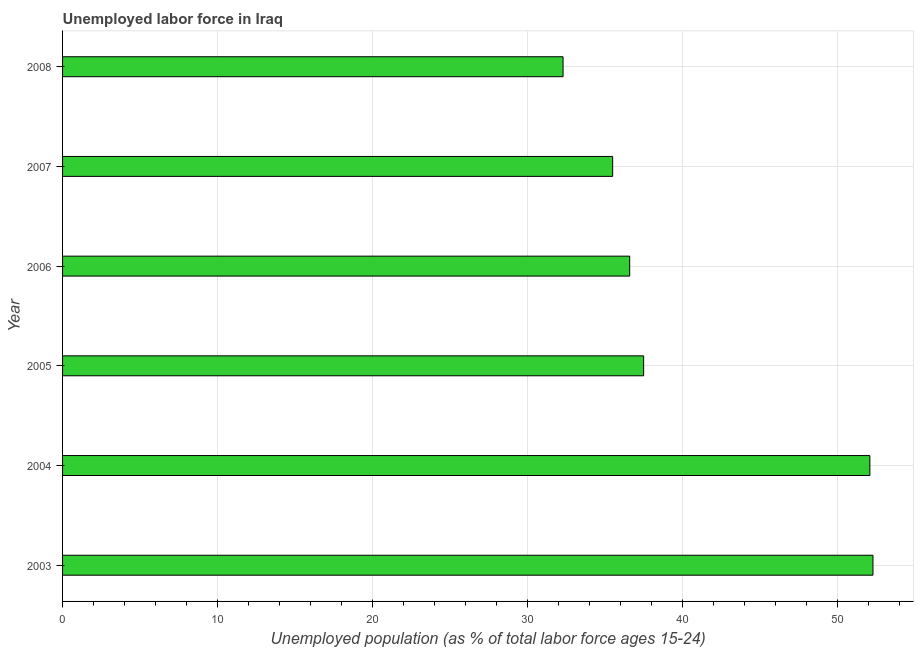Does the graph contain grids?
Provide a succinct answer. Yes. What is the title of the graph?
Offer a very short reply. Unemployed labor force in Iraq. What is the label or title of the X-axis?
Ensure brevity in your answer.  Unemployed population (as % of total labor force ages 15-24). What is the label or title of the Y-axis?
Offer a terse response. Year. What is the total unemployed youth population in 2004?
Your answer should be very brief. 52.1. Across all years, what is the maximum total unemployed youth population?
Give a very brief answer. 52.3. Across all years, what is the minimum total unemployed youth population?
Offer a very short reply. 32.3. What is the sum of the total unemployed youth population?
Provide a succinct answer. 246.3. What is the difference between the total unemployed youth population in 2003 and 2007?
Provide a succinct answer. 16.8. What is the average total unemployed youth population per year?
Make the answer very short. 41.05. What is the median total unemployed youth population?
Make the answer very short. 37.05. In how many years, is the total unemployed youth population greater than 22 %?
Offer a very short reply. 6. What is the ratio of the total unemployed youth population in 2007 to that in 2008?
Your answer should be very brief. 1.1. Is the total unemployed youth population in 2006 less than that in 2008?
Your answer should be compact. No. Is the difference between the total unemployed youth population in 2004 and 2007 greater than the difference between any two years?
Your response must be concise. No. What is the difference between the highest and the second highest total unemployed youth population?
Keep it short and to the point. 0.2. What is the difference between the highest and the lowest total unemployed youth population?
Your answer should be compact. 20. How many bars are there?
Offer a very short reply. 6. Are all the bars in the graph horizontal?
Provide a succinct answer. Yes. What is the difference between two consecutive major ticks on the X-axis?
Ensure brevity in your answer.  10. What is the Unemployed population (as % of total labor force ages 15-24) of 2003?
Offer a terse response. 52.3. What is the Unemployed population (as % of total labor force ages 15-24) of 2004?
Offer a terse response. 52.1. What is the Unemployed population (as % of total labor force ages 15-24) of 2005?
Make the answer very short. 37.5. What is the Unemployed population (as % of total labor force ages 15-24) in 2006?
Offer a terse response. 36.6. What is the Unemployed population (as % of total labor force ages 15-24) of 2007?
Provide a succinct answer. 35.5. What is the Unemployed population (as % of total labor force ages 15-24) in 2008?
Provide a short and direct response. 32.3. What is the difference between the Unemployed population (as % of total labor force ages 15-24) in 2003 and 2005?
Ensure brevity in your answer.  14.8. What is the difference between the Unemployed population (as % of total labor force ages 15-24) in 2003 and 2007?
Your answer should be compact. 16.8. What is the difference between the Unemployed population (as % of total labor force ages 15-24) in 2003 and 2008?
Provide a short and direct response. 20. What is the difference between the Unemployed population (as % of total labor force ages 15-24) in 2004 and 2005?
Provide a short and direct response. 14.6. What is the difference between the Unemployed population (as % of total labor force ages 15-24) in 2004 and 2008?
Your response must be concise. 19.8. What is the difference between the Unemployed population (as % of total labor force ages 15-24) in 2005 and 2006?
Your answer should be very brief. 0.9. What is the difference between the Unemployed population (as % of total labor force ages 15-24) in 2006 and 2008?
Make the answer very short. 4.3. What is the ratio of the Unemployed population (as % of total labor force ages 15-24) in 2003 to that in 2005?
Offer a very short reply. 1.4. What is the ratio of the Unemployed population (as % of total labor force ages 15-24) in 2003 to that in 2006?
Ensure brevity in your answer.  1.43. What is the ratio of the Unemployed population (as % of total labor force ages 15-24) in 2003 to that in 2007?
Offer a terse response. 1.47. What is the ratio of the Unemployed population (as % of total labor force ages 15-24) in 2003 to that in 2008?
Your response must be concise. 1.62. What is the ratio of the Unemployed population (as % of total labor force ages 15-24) in 2004 to that in 2005?
Your answer should be compact. 1.39. What is the ratio of the Unemployed population (as % of total labor force ages 15-24) in 2004 to that in 2006?
Ensure brevity in your answer.  1.42. What is the ratio of the Unemployed population (as % of total labor force ages 15-24) in 2004 to that in 2007?
Make the answer very short. 1.47. What is the ratio of the Unemployed population (as % of total labor force ages 15-24) in 2004 to that in 2008?
Provide a short and direct response. 1.61. What is the ratio of the Unemployed population (as % of total labor force ages 15-24) in 2005 to that in 2006?
Offer a very short reply. 1.02. What is the ratio of the Unemployed population (as % of total labor force ages 15-24) in 2005 to that in 2007?
Offer a terse response. 1.06. What is the ratio of the Unemployed population (as % of total labor force ages 15-24) in 2005 to that in 2008?
Your answer should be compact. 1.16. What is the ratio of the Unemployed population (as % of total labor force ages 15-24) in 2006 to that in 2007?
Keep it short and to the point. 1.03. What is the ratio of the Unemployed population (as % of total labor force ages 15-24) in 2006 to that in 2008?
Offer a very short reply. 1.13. What is the ratio of the Unemployed population (as % of total labor force ages 15-24) in 2007 to that in 2008?
Give a very brief answer. 1.1. 